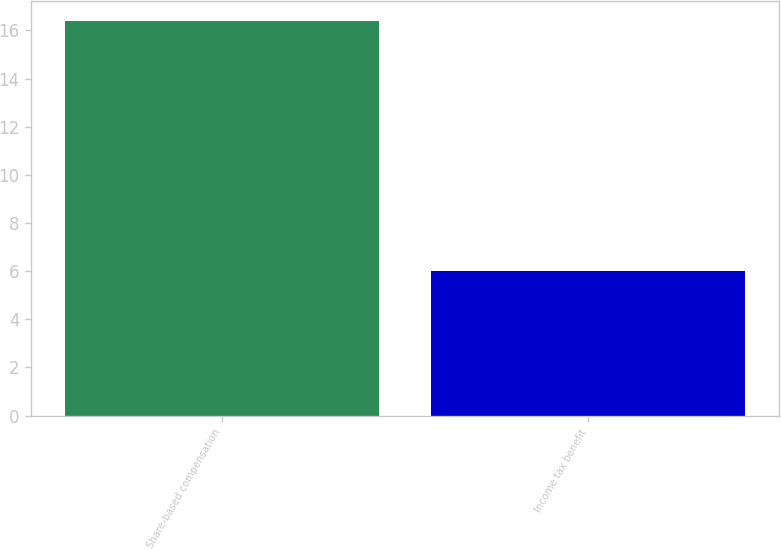<chart> <loc_0><loc_0><loc_500><loc_500><bar_chart><fcel>Share-based compensation<fcel>Income tax benefit<nl><fcel>16.4<fcel>6<nl></chart> 